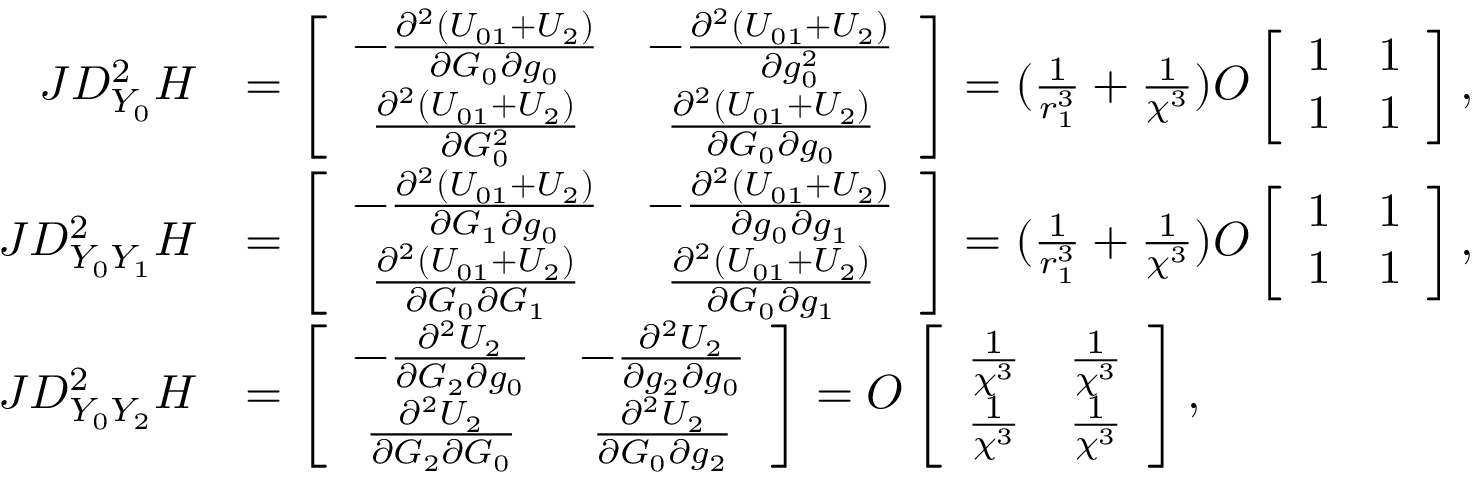<formula> <loc_0><loc_0><loc_500><loc_500>\begin{array} { r l } { J D _ { Y _ { 0 } } ^ { 2 } H } & { = \left [ \begin{array} { c c } { - \frac { \partial ^ { 2 } ( U _ { 0 1 } + U _ { 2 } ) } { \partial G _ { 0 } \partial g _ { 0 } } } & { - \frac { \partial ^ { 2 } ( U _ { 0 1 } + U _ { 2 } ) } { \partial g _ { 0 } ^ { 2 } } } \\ { \frac { \partial ^ { 2 } ( U _ { 0 1 } + U _ { 2 } ) } { \partial G _ { 0 } ^ { 2 } } } & { \frac { \partial ^ { 2 } ( U _ { 0 1 } + U _ { 2 } ) } { \partial G _ { 0 } \partial g _ { 0 } } } \end{array} \right ] = ( \frac { 1 } { r _ { 1 } ^ { 3 } } + \frac { 1 } { \chi ^ { 3 } } ) O \left [ \begin{array} { c c } { 1 } & { 1 } \\ { 1 } & { 1 } \end{array} \right ] , } \\ { J D _ { Y _ { 0 } Y _ { 1 } } ^ { 2 } H } & { = \left [ \begin{array} { c c } { - \frac { \partial ^ { 2 } ( U _ { 0 1 } + U _ { 2 } ) } { \partial G _ { 1 } \partial g _ { 0 } } } & { - \frac { \partial ^ { 2 } ( U _ { 0 1 } + U _ { 2 } ) } { \partial g _ { 0 } \partial g _ { 1 } } } \\ { \frac { \partial ^ { 2 } ( U _ { 0 1 } + U _ { 2 } ) } { \partial G _ { 0 } \partial G _ { 1 } } } & { \frac { \partial ^ { 2 } ( U _ { 0 1 } + U _ { 2 } ) } { \partial G _ { 0 } \partial g _ { 1 } } } \end{array} \right ] = ( \frac { 1 } { r _ { 1 } ^ { 3 } } + \frac { 1 } { \chi ^ { 3 } } ) O \left [ \begin{array} { c c } { 1 } & { 1 } \\ { 1 } & { 1 } \end{array} \right ] , } \\ { J D _ { Y _ { 0 } Y _ { 2 } } ^ { 2 } H } & { = \left [ \begin{array} { c c } { - \frac { \partial ^ { 2 } U _ { 2 } } { \partial G _ { 2 } \partial g _ { 0 } } } & { - \frac { \partial ^ { 2 } U _ { 2 } } { \partial g _ { 2 } \partial g _ { 0 } } } \\ { \frac { \partial ^ { 2 } U _ { 2 } } { \partial G _ { 2 } \partial G _ { 0 } } } & { \frac { \partial ^ { 2 } U _ { 2 } } { \partial G _ { 0 } \partial g _ { 2 } } } \end{array} \right ] = O \left [ \begin{array} { c c } { \frac { 1 } { \chi ^ { 3 } } } & { \frac { 1 } { \chi ^ { 3 } } } \\ { \frac { 1 } { \chi ^ { 3 } } } & { \frac { 1 } { \chi ^ { 3 } } } \end{array} \right ] , } \end{array}</formula> 